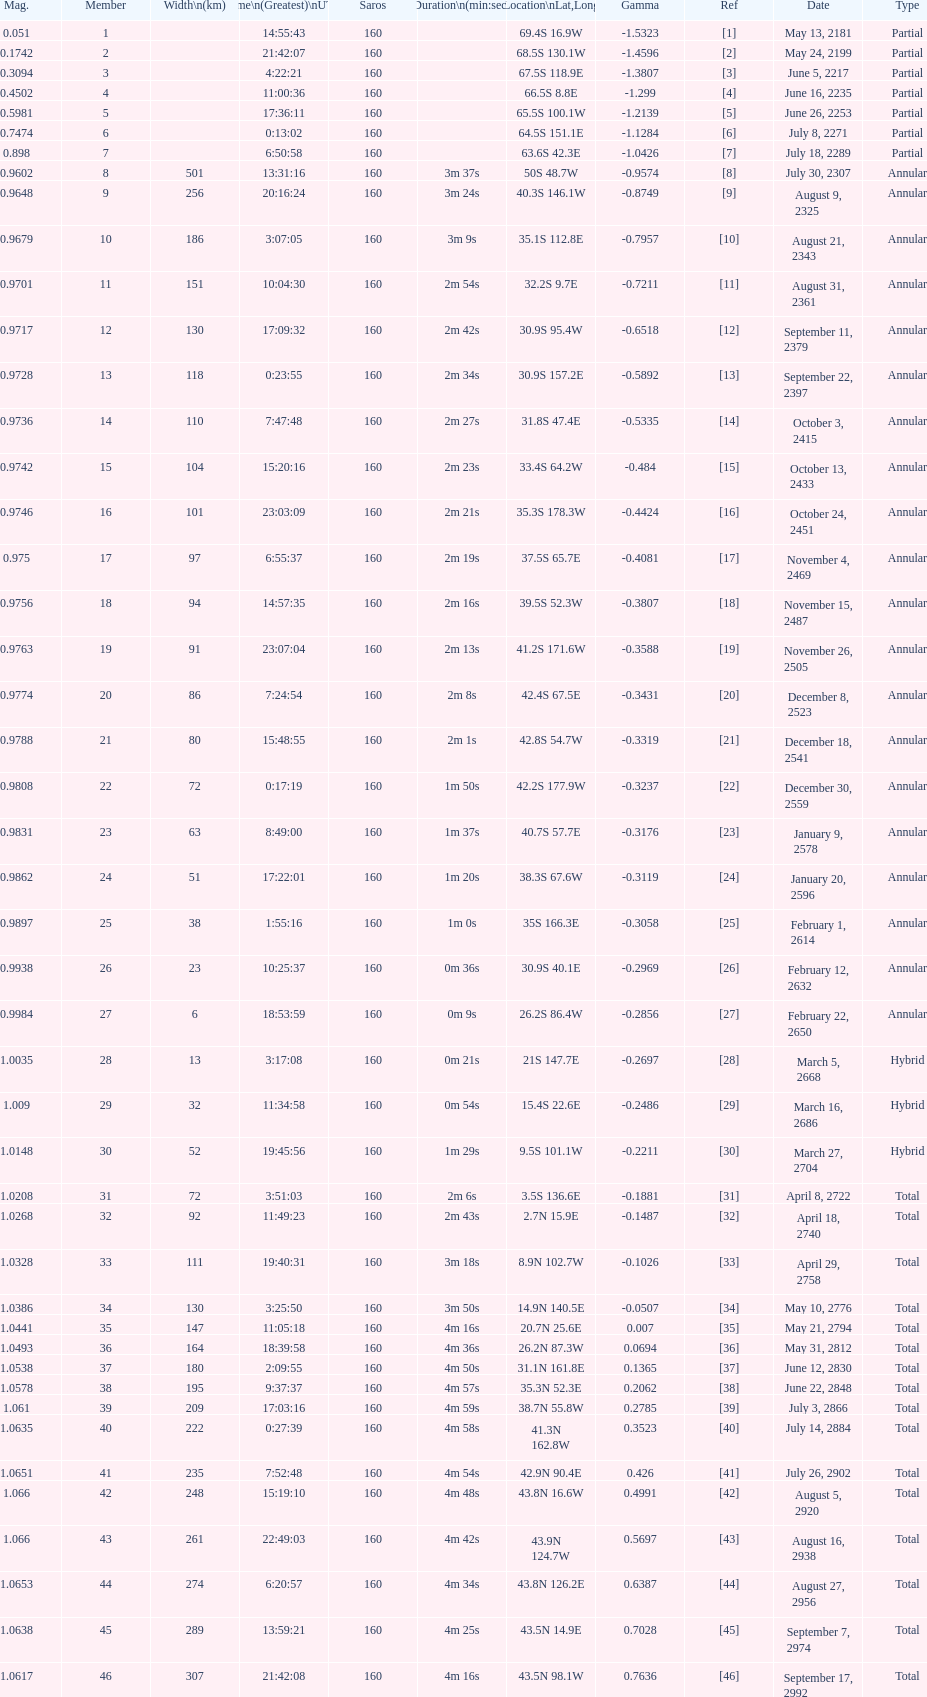How many total events will occur in all? 46. 